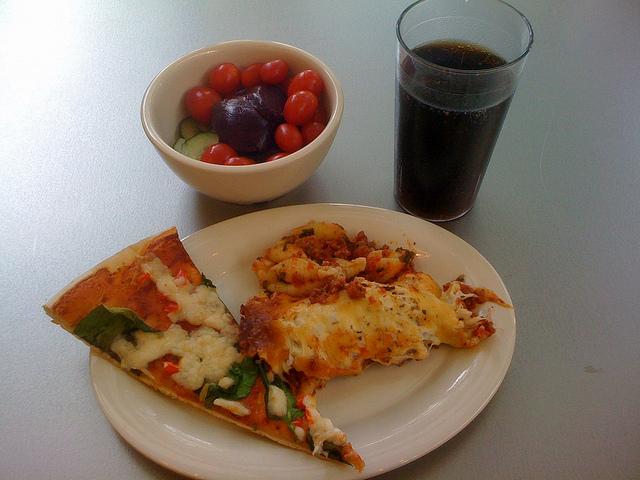What type of Plate is the food on?
Short answer required. Ceramic. Would this be a healthy meal?
Short answer required. No. How many glasses are there?
Quick response, please. 1. Is this a healthy dinner?
Answer briefly. No. Is there any pasta on the plate?
Be succinct. Yes. Is there silverware?
Concise answer only. No. What is in the cup?
Be succinct. Soda. What is the cup made of?
Write a very short answer. Plastic. Is this a formal meal?
Concise answer only. No. What is written on the cup?
Give a very brief answer. Nothing. What fruit is in the bowl?
Concise answer only. Tomatoes. Are there strawberries in the bowl?
Answer briefly. No. What is on the plate?
Answer briefly. Pizza. Which pizza is round?
Quick response, please. None. What is the fruit that is next to the pizza?
Be succinct. Tomatoes. What is in the bowl?
Give a very brief answer. Fruit. 